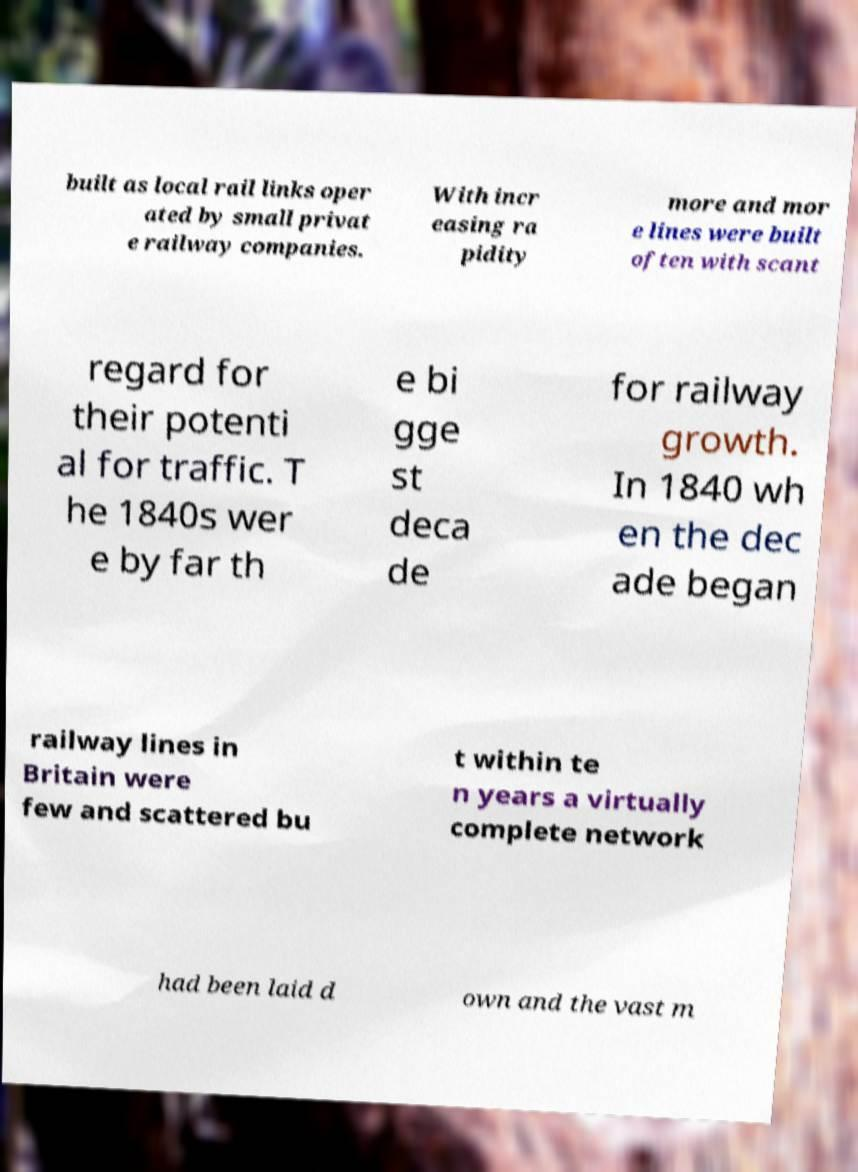Could you assist in decoding the text presented in this image and type it out clearly? built as local rail links oper ated by small privat e railway companies. With incr easing ra pidity more and mor e lines were built often with scant regard for their potenti al for traffic. T he 1840s wer e by far th e bi gge st deca de for railway growth. In 1840 wh en the dec ade began railway lines in Britain were few and scattered bu t within te n years a virtually complete network had been laid d own and the vast m 